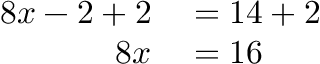<formula> <loc_0><loc_0><loc_500><loc_500>\begin{array} { r l } { 8 x - 2 + 2 } & = 1 4 + 2 } \\ { 8 x } & = 1 6 } \end{array}</formula> 